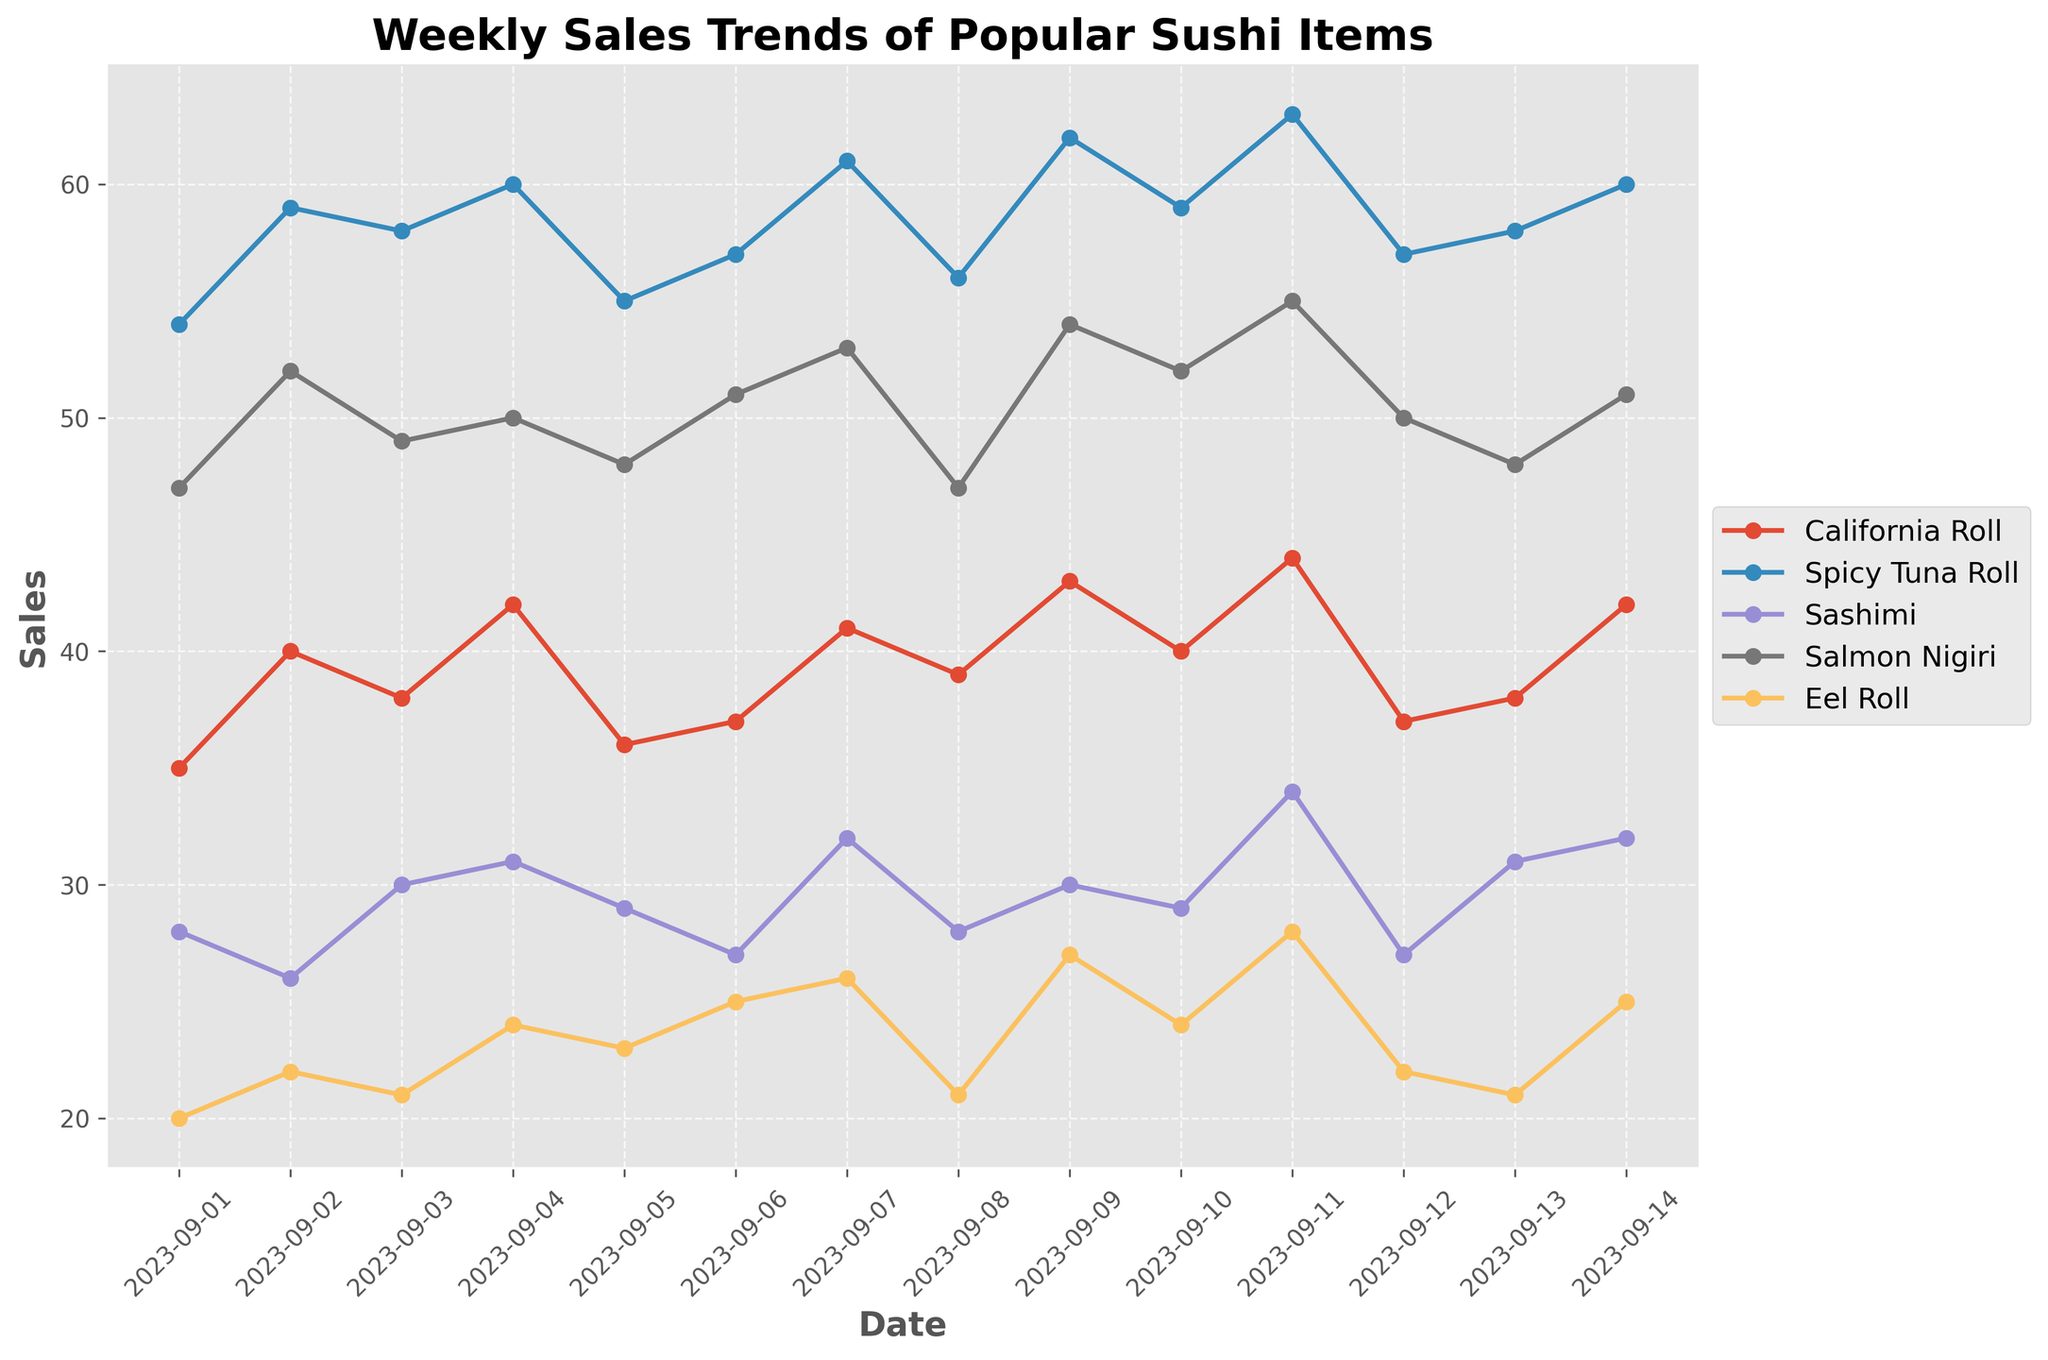What's the title of the figure? The title of the figure can be found at the top of the graph, usually in bigger and bold font. By reading the title, we see it is "Weekly Sales Trends of Popular Sushi Items".
Answer: Weekly Sales Trends of Popular Sushi Items What are the labels on the x-axis and y-axis? By looking at the x-axis and y-axis, we see that the x-axis is labeled "Date" and the y-axis is labeled "Sales".
Answer: Date; Sales How many sushi items are tracked in the plot? By checking the legend which shows the different lines, each corresponding to a sushi item, we can see there are 5 sushi items tracked (California Roll, Spicy Tuna Roll, Sashimi, Salmon Nigiri, Eel Roll).
Answer: 5 Which sushi item had the highest sales on September 7, 2023? To find this, we look at the data points related to September 7, 2023, on the x-axis. From these points, the highest y-axis value is noted for Spicy Tuna Roll (61).
Answer: Spicy Tuna Roll What's the average sales of Salmon Nigiri for the dates shown? Calculate the average by summing the sales of Salmon Nigiri (47, 52, 49, 50, 48, 51, 53, 47, 54, 52, 55, 50, 48, 51) and dividing by the number of data points. The sum is 707 and there are 14 data points, so the average is 707/14.
Answer: 50.5 Which day had the lowest sales for Eel Roll, and what was the sales number? By visually inspecting the plot, we find the lowest point on the Eel Roll line. From the plotted data, the lowest sales number for Eel Roll occurs on September 1, 2023, with a sales number of 20.
Answer: September 1, 2023; 20 Compare the sales trend of California Roll and Spicy Tuna Roll. By comparing the two lines over the same dates, we observe that while both have upward trends, the Spicy Tuna Roll generally has higher sales than the California Roll on most days.
Answer: Spicy Tuna Roll generally higher Which sushi item shows the most consistent sales pattern? By analyzing the variability in the lines for each sushi item, California Roll appears to be the most consistent, showing the least fluctuation across the dates.
Answer: California Roll What was the total sales for Sashimi from September 1 to September 4, 2023? Add the sales values for Sashimi from September 1 to September 4 (28, 26, 30, 31). The total is 28 + 26 + 30 + 31.
Answer: 115 